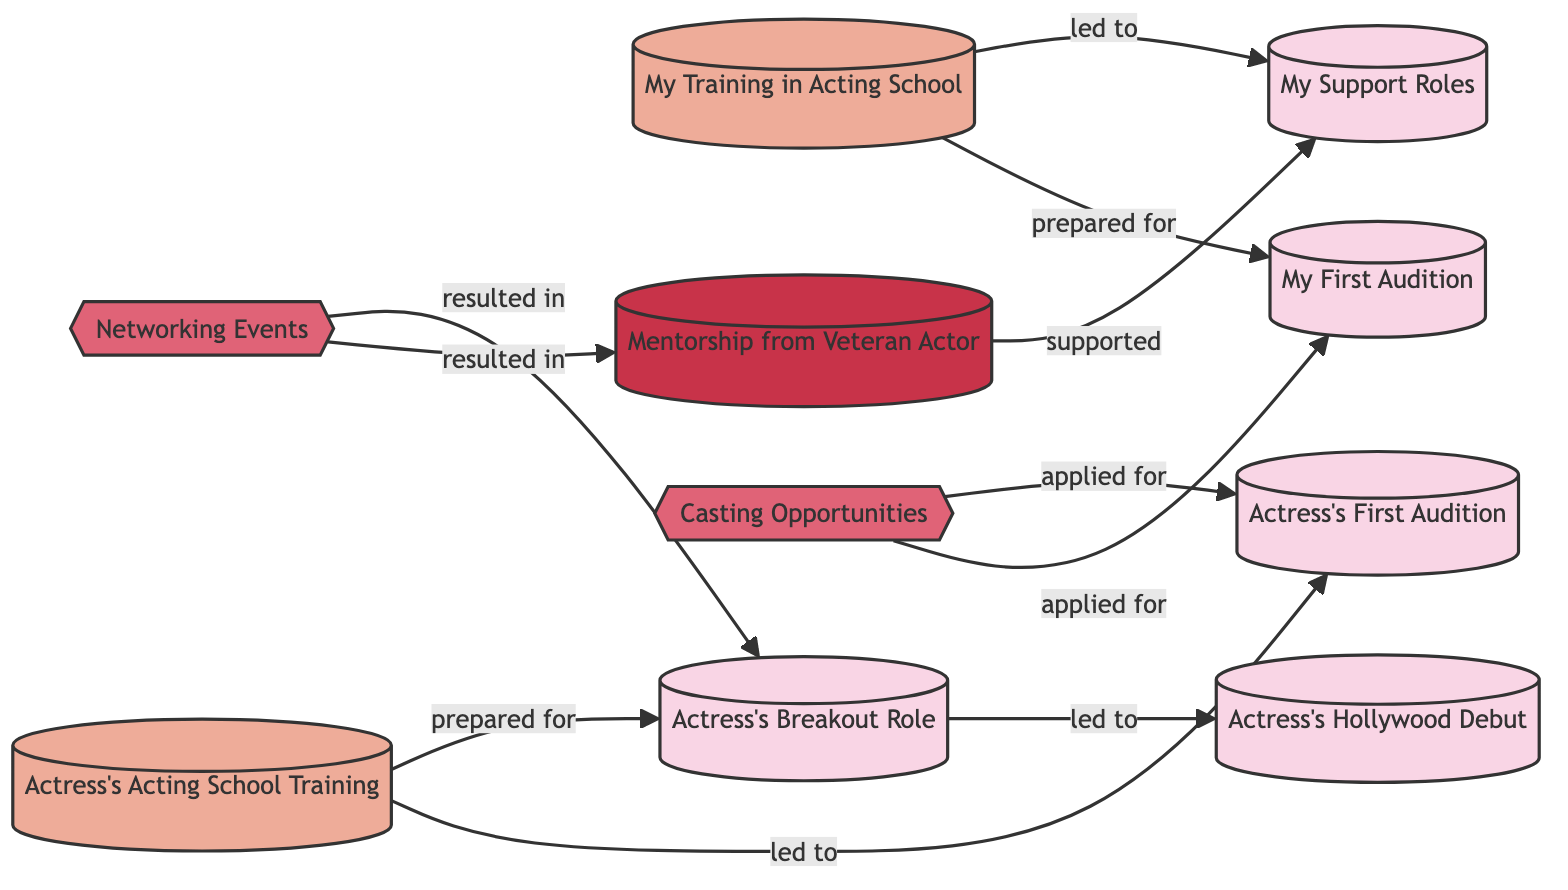What is the first milestone in my journey? The first milestone in the diagram is represented by node 1, labeled "My First Audition."
Answer: My First Audition How many edges are there in the diagram? Counting each connection between nodes, there are a total of 9 edges that describe relationships in the diagram.
Answer: 9 What kind of opportunity is associated with "Actress's First Audition"? The opportunity associated with "Actress's First Audition" is represented by the edge leading from "Casting Opportunities," indicating this node applied for the audition.
Answer: Casting Opportunities Which milestone directly follows "Actress's Breakout Role"? Referring to the directed flow in the diagram, "Actress's Breakout Role" (node 5) leads directly to the milestone "Actress's Hollywood Debut" (node 10).
Answer: Actress's Hollywood Debut What role does the "Mentorship from Veteran Actor" play in my career? In the diagram, the "Mentorship from Veteran Actor" (node 9) supports the milestone of "My Support Roles" (node 2), indicating its importance in my path.
Answer: supported Which education node did I complete before my first audition? According to the diagram, I completed "My Training in Acting School" (node 3) before "My First Audition" (node 1).
Answer: My Training in Acting School What connects "Networking Events" to my support roles? The connection is established through the edge that indicates "Networking Events" (node 8) resulted in "Mentorship from Veteran Actor" (node 9), which in turn supports "My Support Roles" (node 2).
Answer: resulted in How does "Actress's Acting School Training" lead to her breakout role? The diagram shows that "Actress's Acting School Training" (node 6) prepared her for "Actress's Breakout Role" (node 5), illustrating a sequential progression towards this key milestone.
Answer: prepared for Which milestone is a direct outcome of my acting training? The last edge shows that "My Training in Acting School" (node 3) led to "My First Audition" (node 1), indicating that this milestone is directly influenced by my training.
Answer: My First Audition 